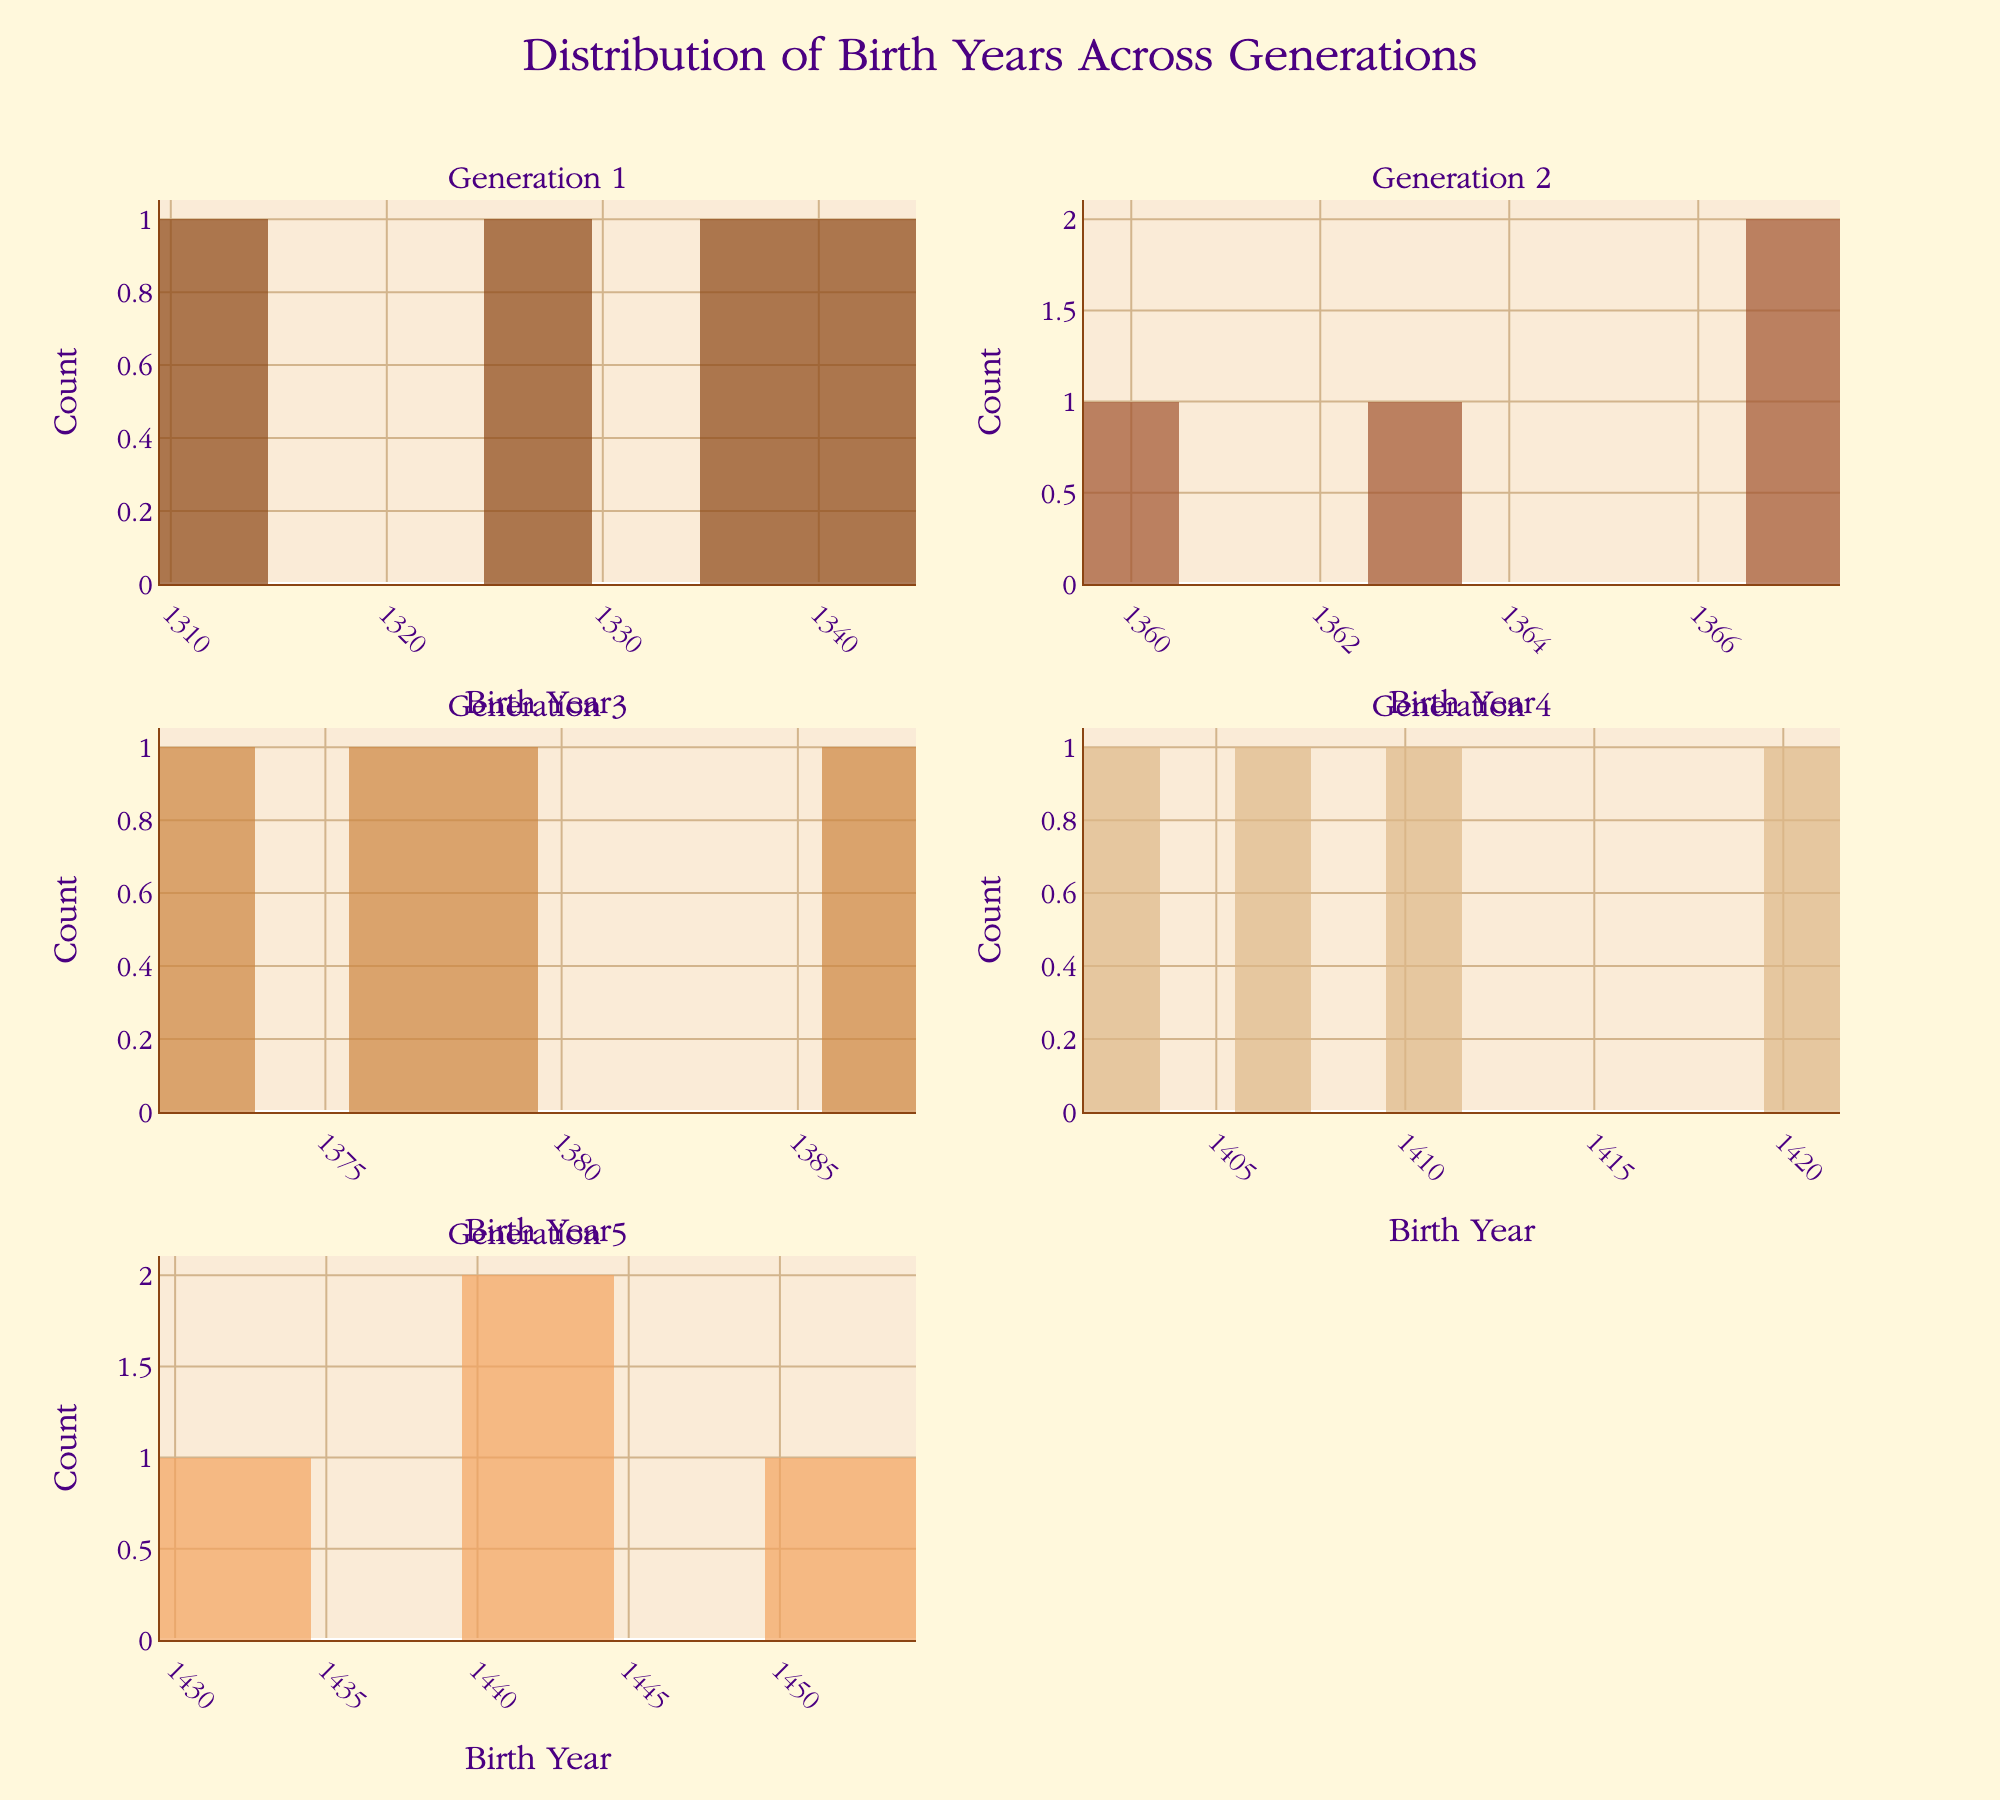What is the title of the figure? The title is usually located at the top center of the figure. The given data mentions the title is "Distribution of Birth Years Across Generations".
Answer: Distribution of Birth Years Across Generations Which generation has the earliest birth year recorded? By looking at the histogram with the earliest birth year on the x-axis, we can observe that Generation 1 contains Edward Plantagenet who was born in 1312.
Answer: Generation 1 What is the most frequent birth year in Generation 2? To determine the most frequent birth year, count the bars in the subplot for Generation 2. The highest bar corresponds to the year 1367, hosting both Richard II and Henry Bolingbroke.
Answer: 1367 How many people were born in Generation 3? Each bar in the histogram represents a count of birth years. By summing the heights of all bars in the subplot for Generation 3, we can conclude that there are 4 individuals (Henry V, John Beaufort, Thomas Beaufort, Joan Beaufort).
Answer: 4 Compare the birth years' range between Generation 1 and Generation 5. Which generation has a wider range? The range is determined by subtracting the minimum birth year from the maximum birth year. For Generation 1: 1340 - 1312 = 28 years. For Generation 5: 1452 - 1430 = 22 years. Generation 1 has a wider range.
Answer: Generation 1 Which generation shows the least variation in birth years? Variation can be observed through the spread of the histogram. Generation 5 appears to have birth years tightly clustered, indicating low variation.
Answer: Generation 5 How many individuals were born around 1403 in Generation 4? Look for bars close to 1403 in the subplot for Generation 4. John Beaufort II was born in 1403.
Answer: 1 What is the average birth year in Generation 3? Average is calculated by summing the birth years and dividing by the number of individuals: (1386 + 1373 + 1377 + 1379) / 4 = 1378.75.
Answer: 1378.75 Compare the count of individuals born in the 1320s and 1330s in Generation 1. Which decade has more individuals? Go through the bars for the 1320s and 1330s in the Generation 1 subplot. The 1320s have Joan of Kent, and the 1330s have Lionel of Antwerp and John of Gaunt. The 1330s have more individuals.
Answer: 1330s Is there any overlap in the birth years of individuals in Generation 3 and Generation 4? Compare the x-axes of Generation 3 and Generation 4 subplots to identify overlap. There is no overlap: Generation 3 spans from 1373-1386, and Generation 4 spans from 1403-1421.
Answer: No 